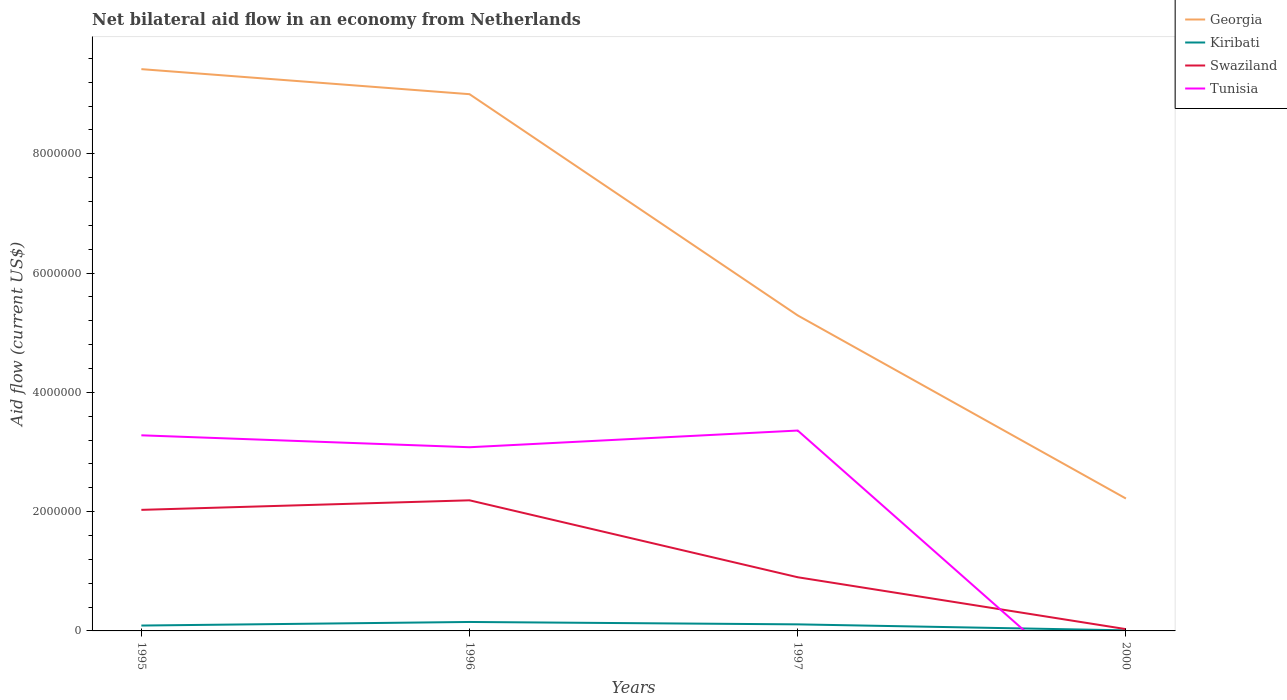Does the line corresponding to Georgia intersect with the line corresponding to Tunisia?
Your answer should be very brief. No. Is the number of lines equal to the number of legend labels?
Your answer should be compact. No. Across all years, what is the maximum net bilateral aid flow in Georgia?
Ensure brevity in your answer.  2.22e+06. What is the total net bilateral aid flow in Tunisia in the graph?
Provide a short and direct response. 2.00e+05. What is the difference between the highest and the second highest net bilateral aid flow in Tunisia?
Offer a very short reply. 3.36e+06. What is the difference between the highest and the lowest net bilateral aid flow in Georgia?
Your answer should be compact. 2. How many years are there in the graph?
Ensure brevity in your answer.  4. Are the values on the major ticks of Y-axis written in scientific E-notation?
Your answer should be very brief. No. Does the graph contain any zero values?
Provide a succinct answer. Yes. Does the graph contain grids?
Offer a very short reply. No. What is the title of the graph?
Your answer should be very brief. Net bilateral aid flow in an economy from Netherlands. Does "Turks and Caicos Islands" appear as one of the legend labels in the graph?
Make the answer very short. No. What is the label or title of the X-axis?
Offer a terse response. Years. What is the label or title of the Y-axis?
Your answer should be compact. Aid flow (current US$). What is the Aid flow (current US$) of Georgia in 1995?
Provide a short and direct response. 9.42e+06. What is the Aid flow (current US$) of Kiribati in 1995?
Offer a terse response. 9.00e+04. What is the Aid flow (current US$) in Swaziland in 1995?
Offer a very short reply. 2.03e+06. What is the Aid flow (current US$) of Tunisia in 1995?
Make the answer very short. 3.28e+06. What is the Aid flow (current US$) of Georgia in 1996?
Ensure brevity in your answer.  9.00e+06. What is the Aid flow (current US$) in Swaziland in 1996?
Offer a very short reply. 2.19e+06. What is the Aid flow (current US$) of Tunisia in 1996?
Make the answer very short. 3.08e+06. What is the Aid flow (current US$) in Georgia in 1997?
Offer a very short reply. 5.29e+06. What is the Aid flow (current US$) of Swaziland in 1997?
Your answer should be compact. 9.00e+05. What is the Aid flow (current US$) of Tunisia in 1997?
Offer a very short reply. 3.36e+06. What is the Aid flow (current US$) of Georgia in 2000?
Make the answer very short. 2.22e+06. Across all years, what is the maximum Aid flow (current US$) in Georgia?
Your response must be concise. 9.42e+06. Across all years, what is the maximum Aid flow (current US$) of Swaziland?
Offer a very short reply. 2.19e+06. Across all years, what is the maximum Aid flow (current US$) of Tunisia?
Ensure brevity in your answer.  3.36e+06. Across all years, what is the minimum Aid flow (current US$) of Georgia?
Provide a short and direct response. 2.22e+06. Across all years, what is the minimum Aid flow (current US$) of Swaziland?
Your answer should be compact. 3.00e+04. What is the total Aid flow (current US$) of Georgia in the graph?
Give a very brief answer. 2.59e+07. What is the total Aid flow (current US$) of Swaziland in the graph?
Your answer should be very brief. 5.15e+06. What is the total Aid flow (current US$) in Tunisia in the graph?
Keep it short and to the point. 9.72e+06. What is the difference between the Aid flow (current US$) of Georgia in 1995 and that in 1996?
Your answer should be very brief. 4.20e+05. What is the difference between the Aid flow (current US$) of Swaziland in 1995 and that in 1996?
Offer a terse response. -1.60e+05. What is the difference between the Aid flow (current US$) of Tunisia in 1995 and that in 1996?
Your response must be concise. 2.00e+05. What is the difference between the Aid flow (current US$) of Georgia in 1995 and that in 1997?
Ensure brevity in your answer.  4.13e+06. What is the difference between the Aid flow (current US$) in Kiribati in 1995 and that in 1997?
Ensure brevity in your answer.  -2.00e+04. What is the difference between the Aid flow (current US$) of Swaziland in 1995 and that in 1997?
Your answer should be very brief. 1.13e+06. What is the difference between the Aid flow (current US$) of Tunisia in 1995 and that in 1997?
Give a very brief answer. -8.00e+04. What is the difference between the Aid flow (current US$) in Georgia in 1995 and that in 2000?
Provide a short and direct response. 7.20e+06. What is the difference between the Aid flow (current US$) of Kiribati in 1995 and that in 2000?
Provide a succinct answer. 8.00e+04. What is the difference between the Aid flow (current US$) of Georgia in 1996 and that in 1997?
Your response must be concise. 3.71e+06. What is the difference between the Aid flow (current US$) in Kiribati in 1996 and that in 1997?
Your response must be concise. 4.00e+04. What is the difference between the Aid flow (current US$) of Swaziland in 1996 and that in 1997?
Provide a short and direct response. 1.29e+06. What is the difference between the Aid flow (current US$) in Tunisia in 1996 and that in 1997?
Provide a succinct answer. -2.80e+05. What is the difference between the Aid flow (current US$) in Georgia in 1996 and that in 2000?
Offer a terse response. 6.78e+06. What is the difference between the Aid flow (current US$) of Swaziland in 1996 and that in 2000?
Provide a succinct answer. 2.16e+06. What is the difference between the Aid flow (current US$) of Georgia in 1997 and that in 2000?
Offer a very short reply. 3.07e+06. What is the difference between the Aid flow (current US$) of Kiribati in 1997 and that in 2000?
Give a very brief answer. 1.00e+05. What is the difference between the Aid flow (current US$) in Swaziland in 1997 and that in 2000?
Make the answer very short. 8.70e+05. What is the difference between the Aid flow (current US$) in Georgia in 1995 and the Aid flow (current US$) in Kiribati in 1996?
Provide a short and direct response. 9.27e+06. What is the difference between the Aid flow (current US$) in Georgia in 1995 and the Aid flow (current US$) in Swaziland in 1996?
Keep it short and to the point. 7.23e+06. What is the difference between the Aid flow (current US$) of Georgia in 1995 and the Aid flow (current US$) of Tunisia in 1996?
Your answer should be very brief. 6.34e+06. What is the difference between the Aid flow (current US$) in Kiribati in 1995 and the Aid flow (current US$) in Swaziland in 1996?
Ensure brevity in your answer.  -2.10e+06. What is the difference between the Aid flow (current US$) in Kiribati in 1995 and the Aid flow (current US$) in Tunisia in 1996?
Your response must be concise. -2.99e+06. What is the difference between the Aid flow (current US$) in Swaziland in 1995 and the Aid flow (current US$) in Tunisia in 1996?
Your response must be concise. -1.05e+06. What is the difference between the Aid flow (current US$) in Georgia in 1995 and the Aid flow (current US$) in Kiribati in 1997?
Offer a terse response. 9.31e+06. What is the difference between the Aid flow (current US$) in Georgia in 1995 and the Aid flow (current US$) in Swaziland in 1997?
Make the answer very short. 8.52e+06. What is the difference between the Aid flow (current US$) of Georgia in 1995 and the Aid flow (current US$) of Tunisia in 1997?
Provide a short and direct response. 6.06e+06. What is the difference between the Aid flow (current US$) in Kiribati in 1995 and the Aid flow (current US$) in Swaziland in 1997?
Give a very brief answer. -8.10e+05. What is the difference between the Aid flow (current US$) of Kiribati in 1995 and the Aid flow (current US$) of Tunisia in 1997?
Provide a short and direct response. -3.27e+06. What is the difference between the Aid flow (current US$) of Swaziland in 1995 and the Aid flow (current US$) of Tunisia in 1997?
Keep it short and to the point. -1.33e+06. What is the difference between the Aid flow (current US$) in Georgia in 1995 and the Aid flow (current US$) in Kiribati in 2000?
Offer a very short reply. 9.41e+06. What is the difference between the Aid flow (current US$) of Georgia in 1995 and the Aid flow (current US$) of Swaziland in 2000?
Provide a short and direct response. 9.39e+06. What is the difference between the Aid flow (current US$) in Kiribati in 1995 and the Aid flow (current US$) in Swaziland in 2000?
Your answer should be compact. 6.00e+04. What is the difference between the Aid flow (current US$) in Georgia in 1996 and the Aid flow (current US$) in Kiribati in 1997?
Your answer should be very brief. 8.89e+06. What is the difference between the Aid flow (current US$) of Georgia in 1996 and the Aid flow (current US$) of Swaziland in 1997?
Keep it short and to the point. 8.10e+06. What is the difference between the Aid flow (current US$) of Georgia in 1996 and the Aid flow (current US$) of Tunisia in 1997?
Offer a terse response. 5.64e+06. What is the difference between the Aid flow (current US$) of Kiribati in 1996 and the Aid flow (current US$) of Swaziland in 1997?
Make the answer very short. -7.50e+05. What is the difference between the Aid flow (current US$) in Kiribati in 1996 and the Aid flow (current US$) in Tunisia in 1997?
Your answer should be compact. -3.21e+06. What is the difference between the Aid flow (current US$) of Swaziland in 1996 and the Aid flow (current US$) of Tunisia in 1997?
Offer a very short reply. -1.17e+06. What is the difference between the Aid flow (current US$) in Georgia in 1996 and the Aid flow (current US$) in Kiribati in 2000?
Ensure brevity in your answer.  8.99e+06. What is the difference between the Aid flow (current US$) in Georgia in 1996 and the Aid flow (current US$) in Swaziland in 2000?
Your answer should be very brief. 8.97e+06. What is the difference between the Aid flow (current US$) in Georgia in 1997 and the Aid flow (current US$) in Kiribati in 2000?
Make the answer very short. 5.28e+06. What is the difference between the Aid flow (current US$) of Georgia in 1997 and the Aid flow (current US$) of Swaziland in 2000?
Your response must be concise. 5.26e+06. What is the average Aid flow (current US$) in Georgia per year?
Make the answer very short. 6.48e+06. What is the average Aid flow (current US$) in Swaziland per year?
Provide a short and direct response. 1.29e+06. What is the average Aid flow (current US$) of Tunisia per year?
Provide a succinct answer. 2.43e+06. In the year 1995, what is the difference between the Aid flow (current US$) of Georgia and Aid flow (current US$) of Kiribati?
Offer a terse response. 9.33e+06. In the year 1995, what is the difference between the Aid flow (current US$) in Georgia and Aid flow (current US$) in Swaziland?
Your answer should be compact. 7.39e+06. In the year 1995, what is the difference between the Aid flow (current US$) in Georgia and Aid flow (current US$) in Tunisia?
Your answer should be compact. 6.14e+06. In the year 1995, what is the difference between the Aid flow (current US$) in Kiribati and Aid flow (current US$) in Swaziland?
Make the answer very short. -1.94e+06. In the year 1995, what is the difference between the Aid flow (current US$) of Kiribati and Aid flow (current US$) of Tunisia?
Make the answer very short. -3.19e+06. In the year 1995, what is the difference between the Aid flow (current US$) of Swaziland and Aid flow (current US$) of Tunisia?
Make the answer very short. -1.25e+06. In the year 1996, what is the difference between the Aid flow (current US$) of Georgia and Aid flow (current US$) of Kiribati?
Offer a terse response. 8.85e+06. In the year 1996, what is the difference between the Aid flow (current US$) of Georgia and Aid flow (current US$) of Swaziland?
Ensure brevity in your answer.  6.81e+06. In the year 1996, what is the difference between the Aid flow (current US$) in Georgia and Aid flow (current US$) in Tunisia?
Your response must be concise. 5.92e+06. In the year 1996, what is the difference between the Aid flow (current US$) of Kiribati and Aid flow (current US$) of Swaziland?
Offer a very short reply. -2.04e+06. In the year 1996, what is the difference between the Aid flow (current US$) in Kiribati and Aid flow (current US$) in Tunisia?
Keep it short and to the point. -2.93e+06. In the year 1996, what is the difference between the Aid flow (current US$) of Swaziland and Aid flow (current US$) of Tunisia?
Provide a succinct answer. -8.90e+05. In the year 1997, what is the difference between the Aid flow (current US$) in Georgia and Aid flow (current US$) in Kiribati?
Ensure brevity in your answer.  5.18e+06. In the year 1997, what is the difference between the Aid flow (current US$) in Georgia and Aid flow (current US$) in Swaziland?
Offer a terse response. 4.39e+06. In the year 1997, what is the difference between the Aid flow (current US$) of Georgia and Aid flow (current US$) of Tunisia?
Your answer should be compact. 1.93e+06. In the year 1997, what is the difference between the Aid flow (current US$) of Kiribati and Aid flow (current US$) of Swaziland?
Your response must be concise. -7.90e+05. In the year 1997, what is the difference between the Aid flow (current US$) in Kiribati and Aid flow (current US$) in Tunisia?
Your response must be concise. -3.25e+06. In the year 1997, what is the difference between the Aid flow (current US$) in Swaziland and Aid flow (current US$) in Tunisia?
Ensure brevity in your answer.  -2.46e+06. In the year 2000, what is the difference between the Aid flow (current US$) in Georgia and Aid flow (current US$) in Kiribati?
Provide a succinct answer. 2.21e+06. In the year 2000, what is the difference between the Aid flow (current US$) of Georgia and Aid flow (current US$) of Swaziland?
Provide a succinct answer. 2.19e+06. In the year 2000, what is the difference between the Aid flow (current US$) in Kiribati and Aid flow (current US$) in Swaziland?
Your response must be concise. -2.00e+04. What is the ratio of the Aid flow (current US$) in Georgia in 1995 to that in 1996?
Offer a terse response. 1.05. What is the ratio of the Aid flow (current US$) of Kiribati in 1995 to that in 1996?
Offer a terse response. 0.6. What is the ratio of the Aid flow (current US$) in Swaziland in 1995 to that in 1996?
Ensure brevity in your answer.  0.93. What is the ratio of the Aid flow (current US$) in Tunisia in 1995 to that in 1996?
Make the answer very short. 1.06. What is the ratio of the Aid flow (current US$) in Georgia in 1995 to that in 1997?
Provide a succinct answer. 1.78. What is the ratio of the Aid flow (current US$) of Kiribati in 1995 to that in 1997?
Offer a terse response. 0.82. What is the ratio of the Aid flow (current US$) in Swaziland in 1995 to that in 1997?
Offer a very short reply. 2.26. What is the ratio of the Aid flow (current US$) of Tunisia in 1995 to that in 1997?
Offer a terse response. 0.98. What is the ratio of the Aid flow (current US$) of Georgia in 1995 to that in 2000?
Give a very brief answer. 4.24. What is the ratio of the Aid flow (current US$) of Kiribati in 1995 to that in 2000?
Ensure brevity in your answer.  9. What is the ratio of the Aid flow (current US$) in Swaziland in 1995 to that in 2000?
Provide a short and direct response. 67.67. What is the ratio of the Aid flow (current US$) in Georgia in 1996 to that in 1997?
Make the answer very short. 1.7. What is the ratio of the Aid flow (current US$) in Kiribati in 1996 to that in 1997?
Your answer should be compact. 1.36. What is the ratio of the Aid flow (current US$) of Swaziland in 1996 to that in 1997?
Your answer should be compact. 2.43. What is the ratio of the Aid flow (current US$) of Georgia in 1996 to that in 2000?
Provide a succinct answer. 4.05. What is the ratio of the Aid flow (current US$) in Kiribati in 1996 to that in 2000?
Offer a very short reply. 15. What is the ratio of the Aid flow (current US$) of Swaziland in 1996 to that in 2000?
Give a very brief answer. 73. What is the ratio of the Aid flow (current US$) in Georgia in 1997 to that in 2000?
Offer a terse response. 2.38. What is the ratio of the Aid flow (current US$) in Kiribati in 1997 to that in 2000?
Provide a succinct answer. 11. What is the difference between the highest and the second highest Aid flow (current US$) in Georgia?
Give a very brief answer. 4.20e+05. What is the difference between the highest and the lowest Aid flow (current US$) in Georgia?
Offer a very short reply. 7.20e+06. What is the difference between the highest and the lowest Aid flow (current US$) in Swaziland?
Give a very brief answer. 2.16e+06. What is the difference between the highest and the lowest Aid flow (current US$) in Tunisia?
Provide a short and direct response. 3.36e+06. 